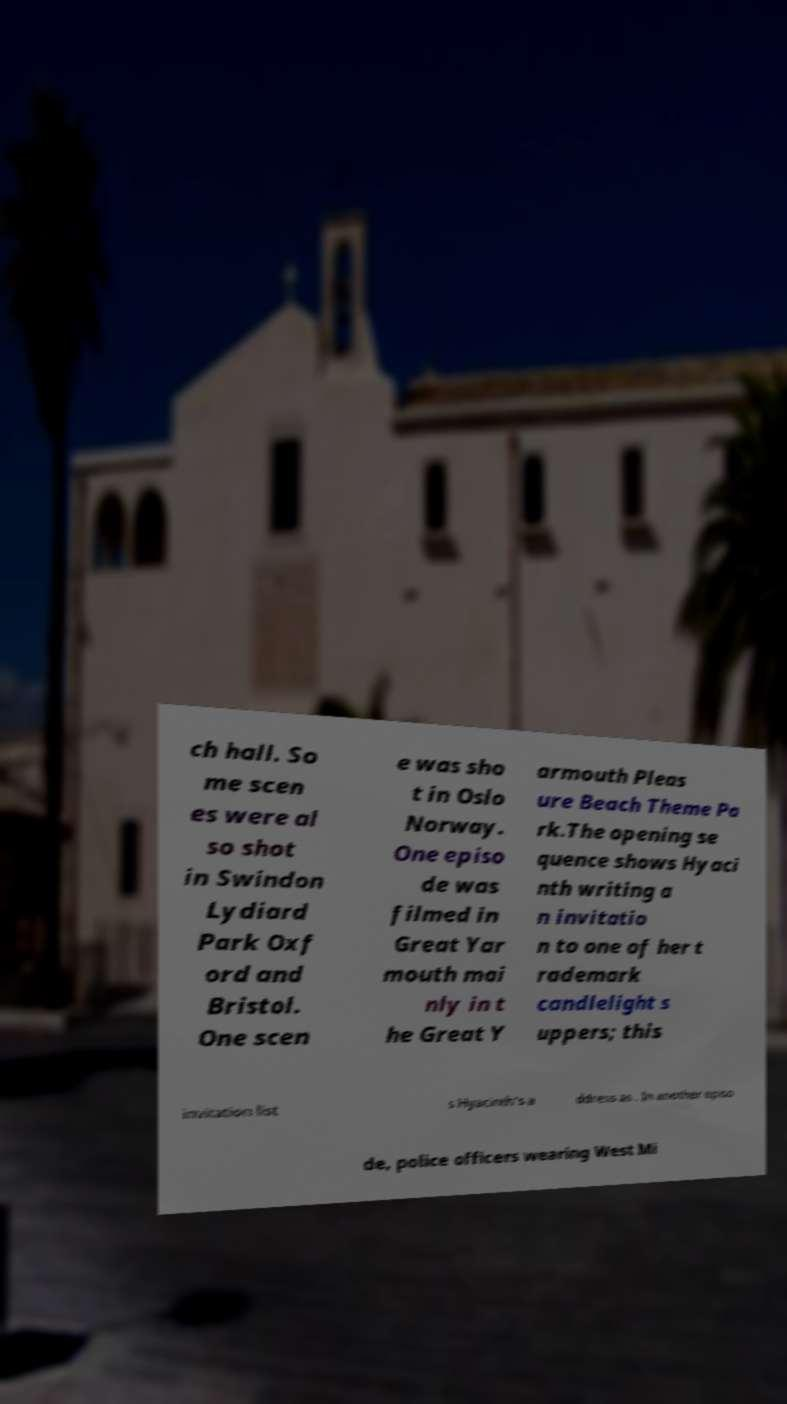Can you accurately transcribe the text from the provided image for me? ch hall. So me scen es were al so shot in Swindon Lydiard Park Oxf ord and Bristol. One scen e was sho t in Oslo Norway. One episo de was filmed in Great Yar mouth mai nly in t he Great Y armouth Pleas ure Beach Theme Pa rk.The opening se quence shows Hyaci nth writing a n invitatio n to one of her t rademark candlelight s uppers; this invitation list s Hyacinth's a ddress as . In another episo de, police officers wearing West Mi 